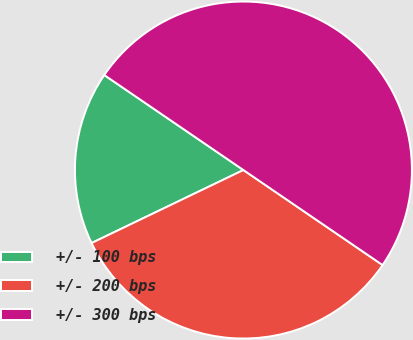<chart> <loc_0><loc_0><loc_500><loc_500><pie_chart><fcel>+/- 100 bps<fcel>+/- 200 bps<fcel>+/- 300 bps<nl><fcel>16.67%<fcel>33.33%<fcel>50.0%<nl></chart> 